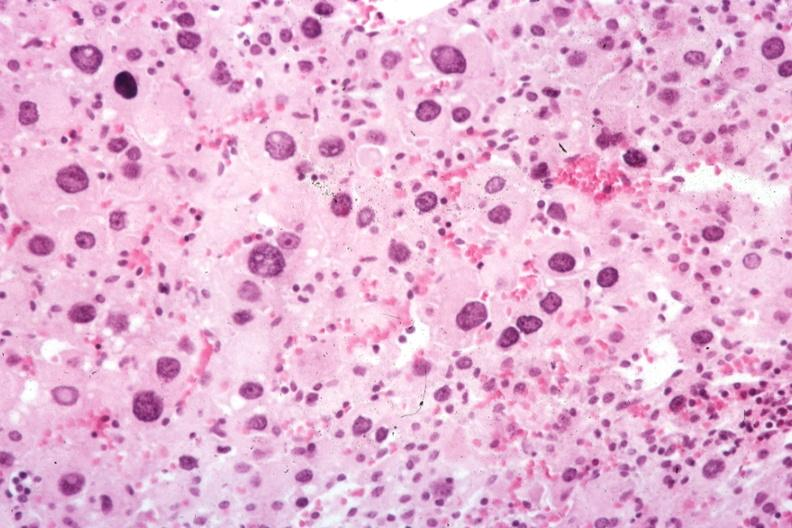what is present?
Answer the question using a single word or phrase. Adrenal 